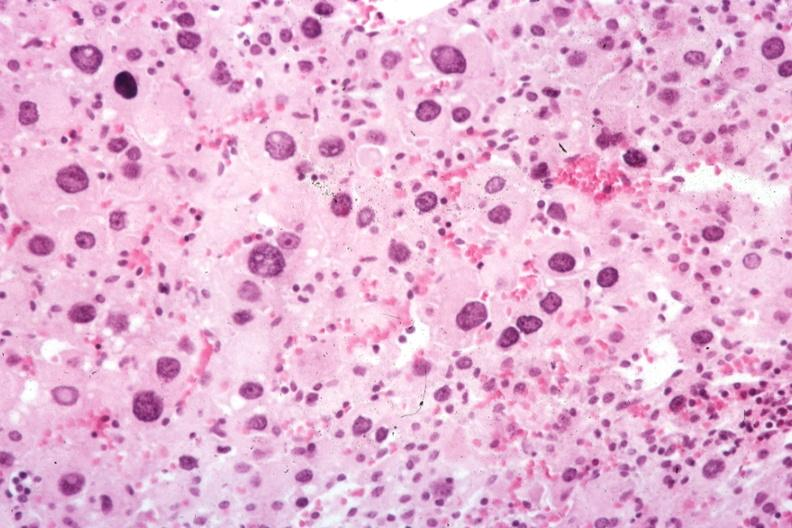what is present?
Answer the question using a single word or phrase. Adrenal 